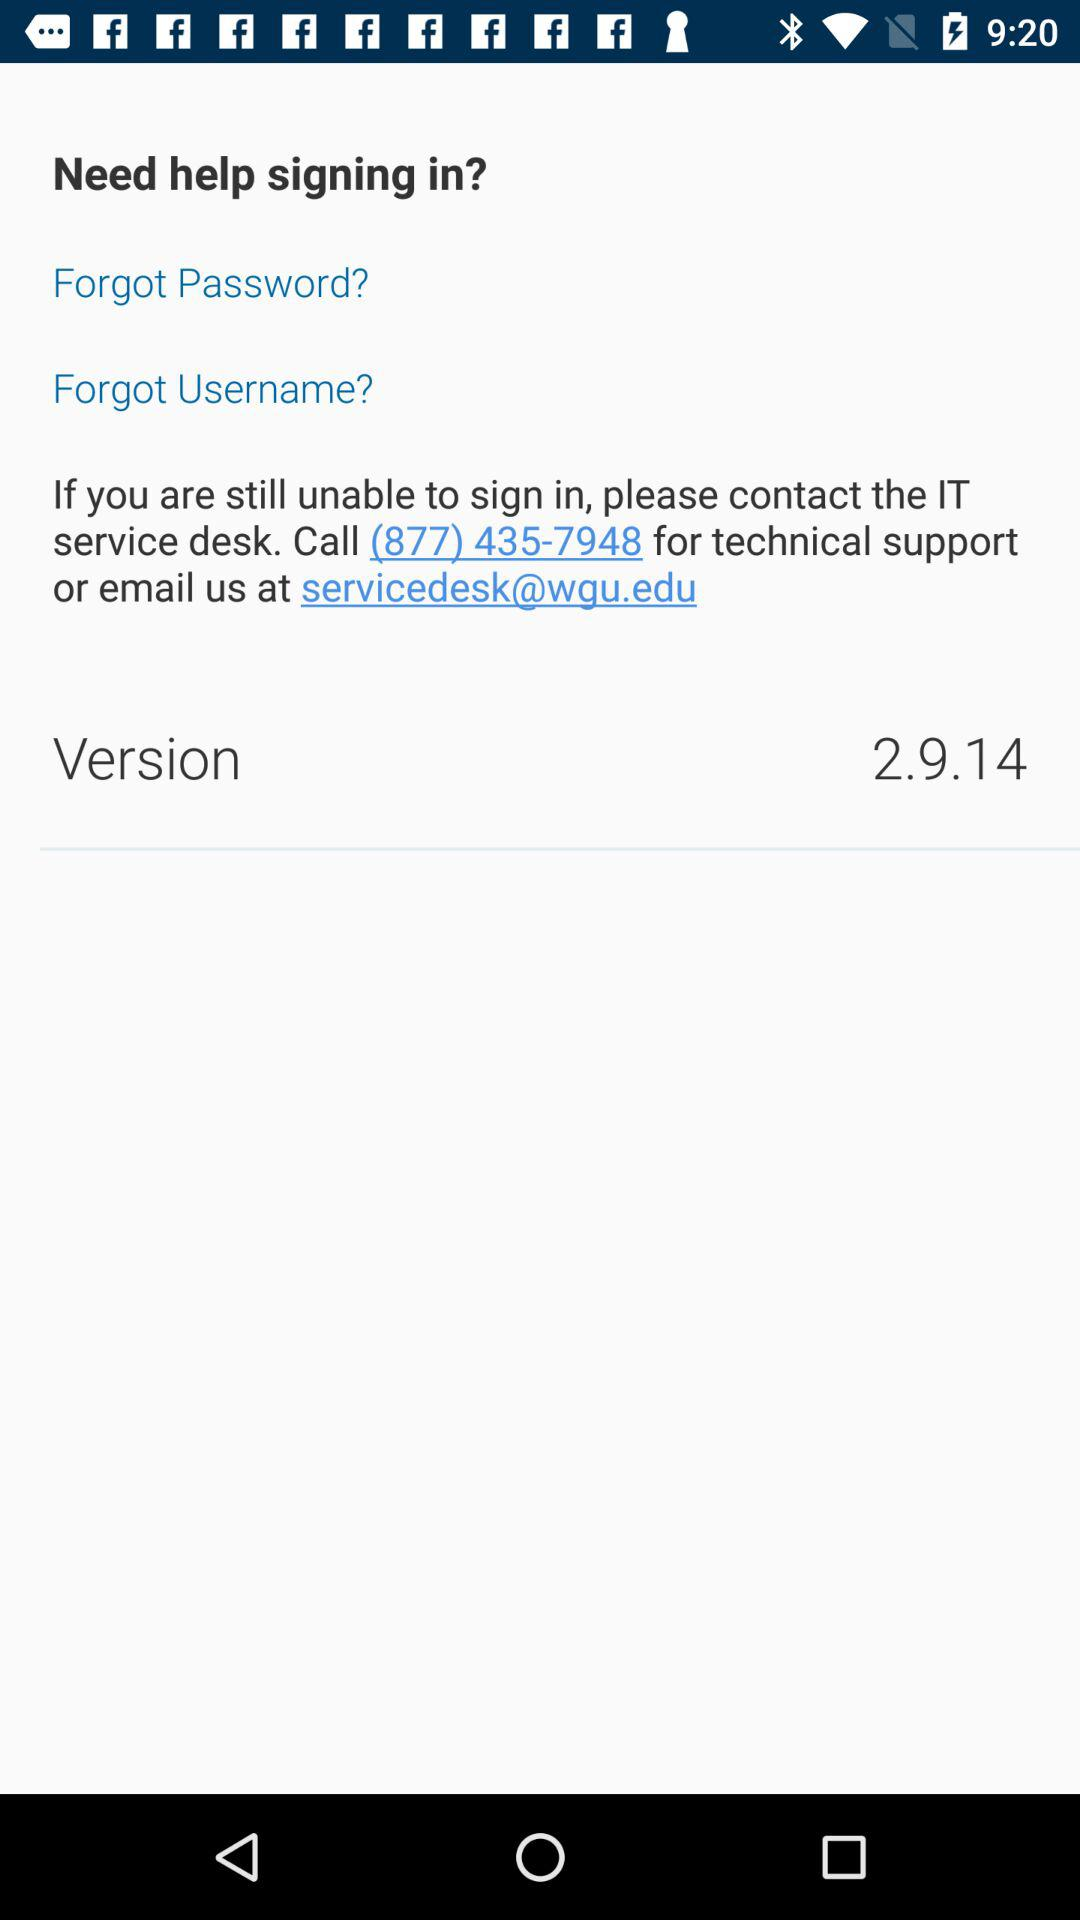What is the technical support number given on the screen? The technical support number given on the screen is (877) 435-7948. 